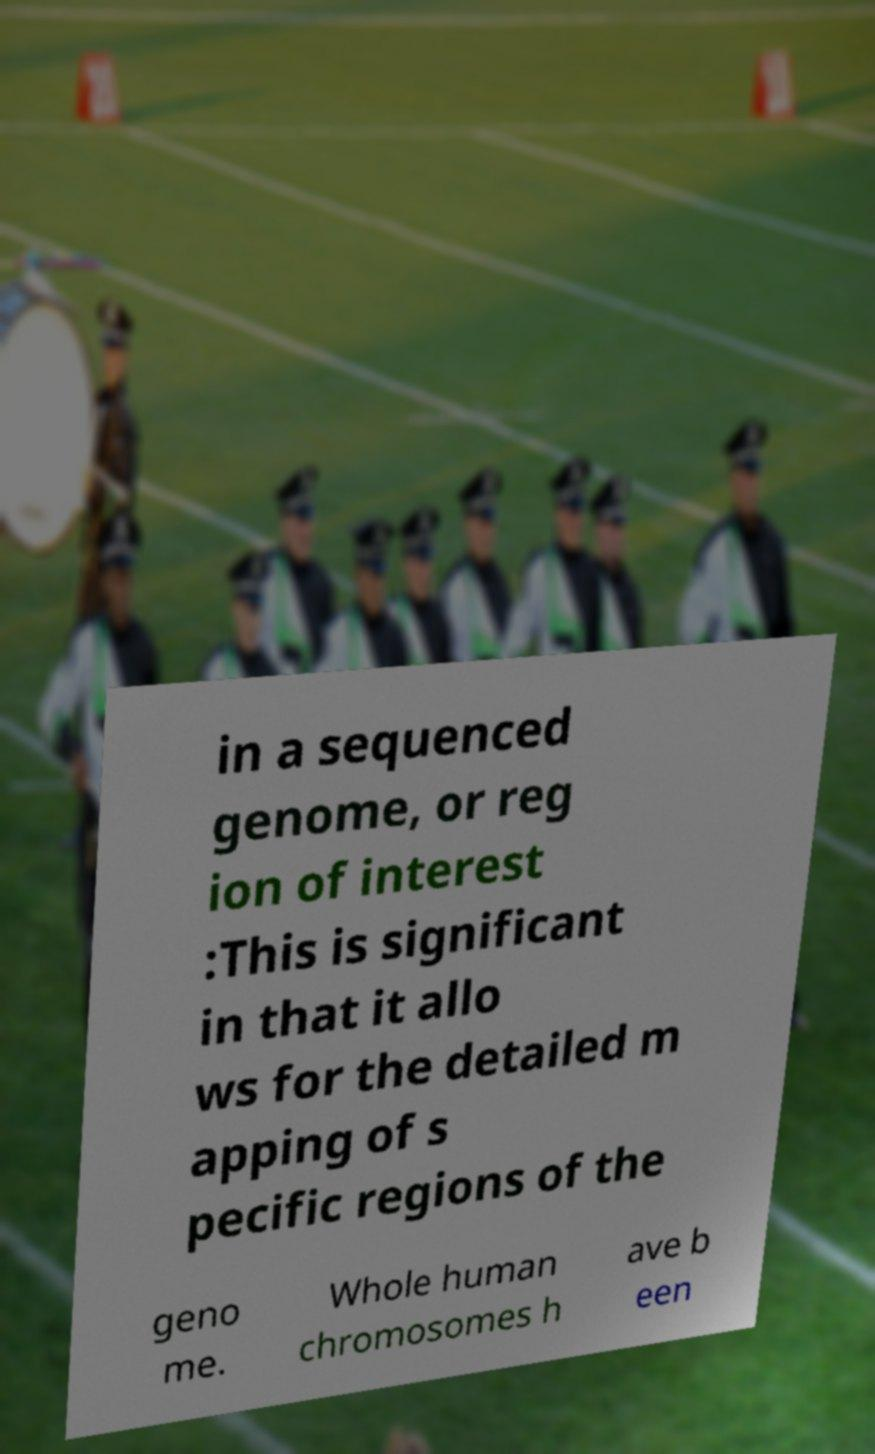Could you extract and type out the text from this image? in a sequenced genome, or reg ion of interest :This is significant in that it allo ws for the detailed m apping of s pecific regions of the geno me. Whole human chromosomes h ave b een 